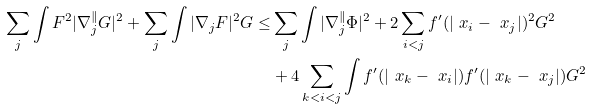Convert formula to latex. <formula><loc_0><loc_0><loc_500><loc_500>\sum _ { j } \int F ^ { 2 } | \nabla ^ { \| } _ { j } G | ^ { 2 } + \sum _ { j } \int | \nabla _ { j } F | ^ { 2 } G \leq & \sum _ { j } \int | \nabla _ { j } ^ { \| } \Phi | ^ { 2 } + 2 \sum _ { i < j } f ^ { \prime } ( | \ x _ { i } - \ x _ { j } | ) ^ { 2 } G ^ { 2 } \\ & + 4 \sum _ { k < i < j } \int f ^ { \prime } ( | \ x _ { k } - \ x _ { i } | ) f ^ { \prime } ( | \ x _ { k } - \ x _ { j } | ) G ^ { 2 } \\</formula> 